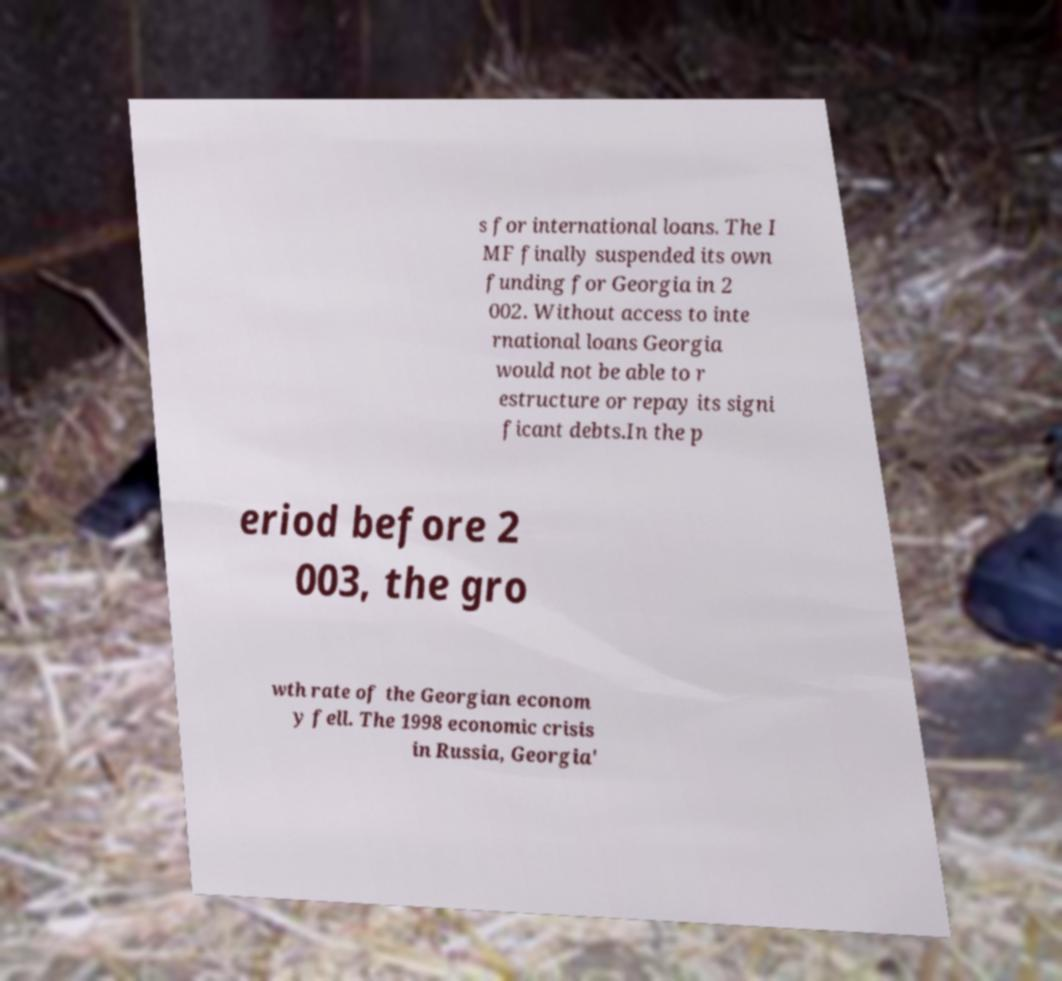Please read and relay the text visible in this image. What does it say? s for international loans. The I MF finally suspended its own funding for Georgia in 2 002. Without access to inte rnational loans Georgia would not be able to r estructure or repay its signi ficant debts.In the p eriod before 2 003, the gro wth rate of the Georgian econom y fell. The 1998 economic crisis in Russia, Georgia' 